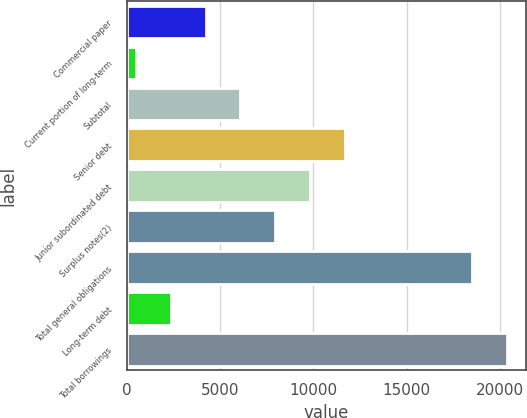Convert chart to OTSL. <chart><loc_0><loc_0><loc_500><loc_500><bar_chart><fcel>Commercial paper<fcel>Current portion of long-term<fcel>Subtotal<fcel>Senior debt<fcel>Junior subordinated debt<fcel>Surplus notes(2)<fcel>Total general obligations<fcel>Long-term debt<fcel>Total borrowings<nl><fcel>4210.8<fcel>470<fcel>6081.2<fcel>11692.4<fcel>9822<fcel>7951.6<fcel>18515<fcel>2340.4<fcel>20385.4<nl></chart> 